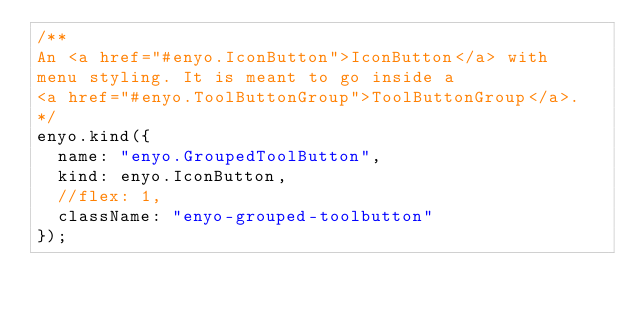Convert code to text. <code><loc_0><loc_0><loc_500><loc_500><_JavaScript_>/**
An <a href="#enyo.IconButton">IconButton</a> with
menu styling. It is meant to go inside a
<a href="#enyo.ToolButtonGroup">ToolButtonGroup</a>.
*/
enyo.kind({
	name: "enyo.GroupedToolButton",
	kind: enyo.IconButton,
	//flex: 1,
	className: "enyo-grouped-toolbutton"
});
</code> 